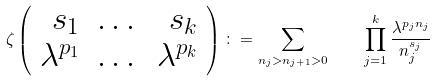<formula> <loc_0><loc_0><loc_500><loc_500>\zeta \left ( \begin{array} { r c r } s _ { 1 } & \dots & s _ { k } \\ \lambda ^ { p _ { 1 } } & \dots & \lambda ^ { p _ { k } } \end{array} \right ) \colon = \sum _ { n _ { j } > n _ { j + 1 } > 0 } \quad \prod _ { j = 1 } ^ { k } \frac { \lambda ^ { p _ { j } n _ { j } } } { n _ { j } ^ { s _ { j } } }</formula> 